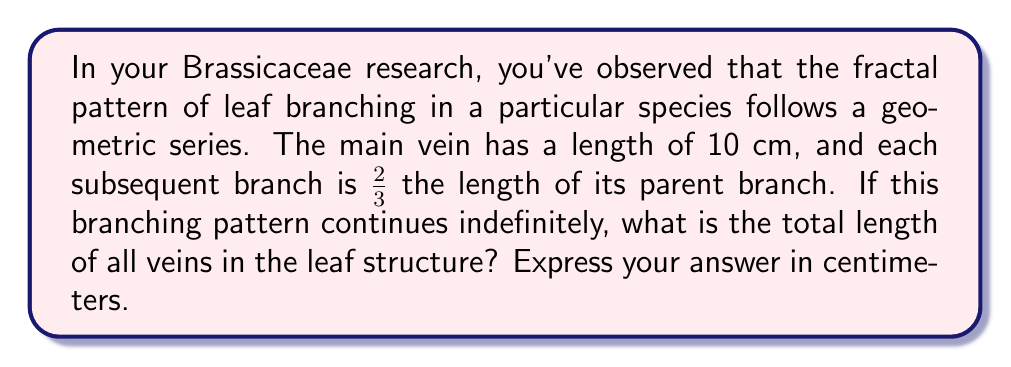Teach me how to tackle this problem. To solve this problem, we need to use the formula for the sum of an infinite geometric series:

$$S_{\infty} = \frac{a}{1-r}$$

Where:
$S_{\infty}$ is the sum of the infinite series
$a$ is the first term
$r$ is the common ratio

In this case:
$a = 10$ cm (the length of the main vein)
$r = \frac{2}{3}$ (the ratio of each subsequent branch to its parent)

Let's verify that $|r| < 1$, which is a requirement for the series to converge:

$$|\frac{2}{3}| = \frac{2}{3} < 1$$

This condition is satisfied, so we can proceed with the formula.

Substituting the values into the formula:

$$S_{\infty} = \frac{10}{1-\frac{2}{3}}$$

Simplifying:

$$S_{\infty} = \frac{10}{\frac{3}{3}-\frac{2}{3}} = \frac{10}{\frac{1}{3}}$$

$$S_{\infty} = 10 \cdot 3 = 30$$

Therefore, the total length of all veins in the leaf structure is 30 cm.
Answer: 30 cm 